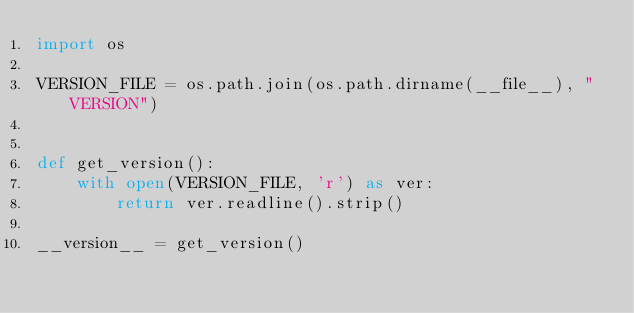Convert code to text. <code><loc_0><loc_0><loc_500><loc_500><_Python_>import os

VERSION_FILE = os.path.join(os.path.dirname(__file__), "VERSION")


def get_version():
    with open(VERSION_FILE, 'r') as ver:
        return ver.readline().strip()

__version__ = get_version()
</code> 